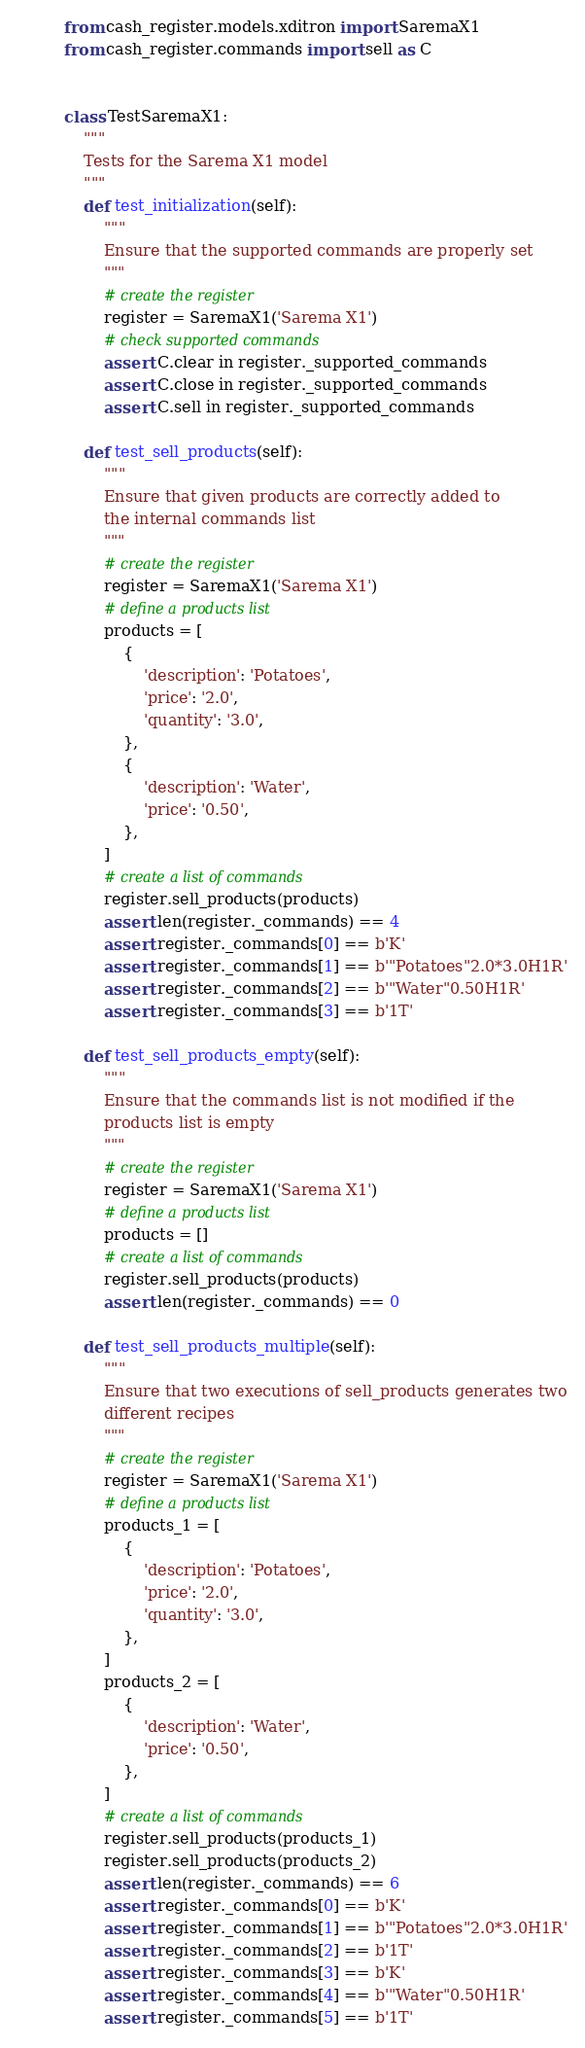Convert code to text. <code><loc_0><loc_0><loc_500><loc_500><_Python_>from cash_register.models.xditron import SaremaX1
from cash_register.commands import sell as C


class TestSaremaX1:
    """
    Tests for the Sarema X1 model
    """
    def test_initialization(self):
        """
        Ensure that the supported commands are properly set
        """
        # create the register
        register = SaremaX1('Sarema X1')
        # check supported commands
        assert C.clear in register._supported_commands
        assert C.close in register._supported_commands
        assert C.sell in register._supported_commands

    def test_sell_products(self):
        """
        Ensure that given products are correctly added to
        the internal commands list
        """
        # create the register
        register = SaremaX1('Sarema X1')
        # define a products list
        products = [
            {
                'description': 'Potatoes',
                'price': '2.0',
                'quantity': '3.0',
            },
            {
                'description': 'Water',
                'price': '0.50',
            },
        ]
        # create a list of commands
        register.sell_products(products)
        assert len(register._commands) == 4
        assert register._commands[0] == b'K'
        assert register._commands[1] == b'"Potatoes"2.0*3.0H1R'
        assert register._commands[2] == b'"Water"0.50H1R'
        assert register._commands[3] == b'1T'

    def test_sell_products_empty(self):
        """
        Ensure that the commands list is not modified if the
        products list is empty
        """
        # create the register
        register = SaremaX1('Sarema X1')
        # define a products list
        products = []
        # create a list of commands
        register.sell_products(products)
        assert len(register._commands) == 0

    def test_sell_products_multiple(self):
        """
        Ensure that two executions of sell_products generates two
        different recipes
        """
        # create the register
        register = SaremaX1('Sarema X1')
        # define a products list
        products_1 = [
            {
                'description': 'Potatoes',
                'price': '2.0',
                'quantity': '3.0',
            },
        ]
        products_2 = [
            {
                'description': 'Water',
                'price': '0.50',
            },
        ]
        # create a list of commands
        register.sell_products(products_1)
        register.sell_products(products_2)
        assert len(register._commands) == 6
        assert register._commands[0] == b'K'
        assert register._commands[1] == b'"Potatoes"2.0*3.0H1R'
        assert register._commands[2] == b'1T'
        assert register._commands[3] == b'K'
        assert register._commands[4] == b'"Water"0.50H1R'
        assert register._commands[5] == b'1T'
</code> 